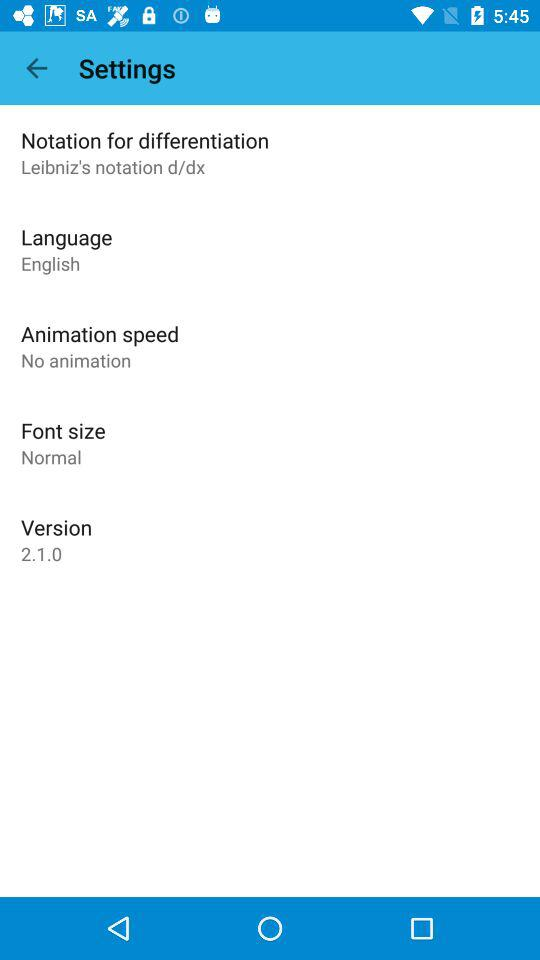When was version 2.1.0 updated?
When the provided information is insufficient, respond with <no answer>. <no answer> 